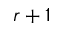<formula> <loc_0><loc_0><loc_500><loc_500>r + 1</formula> 